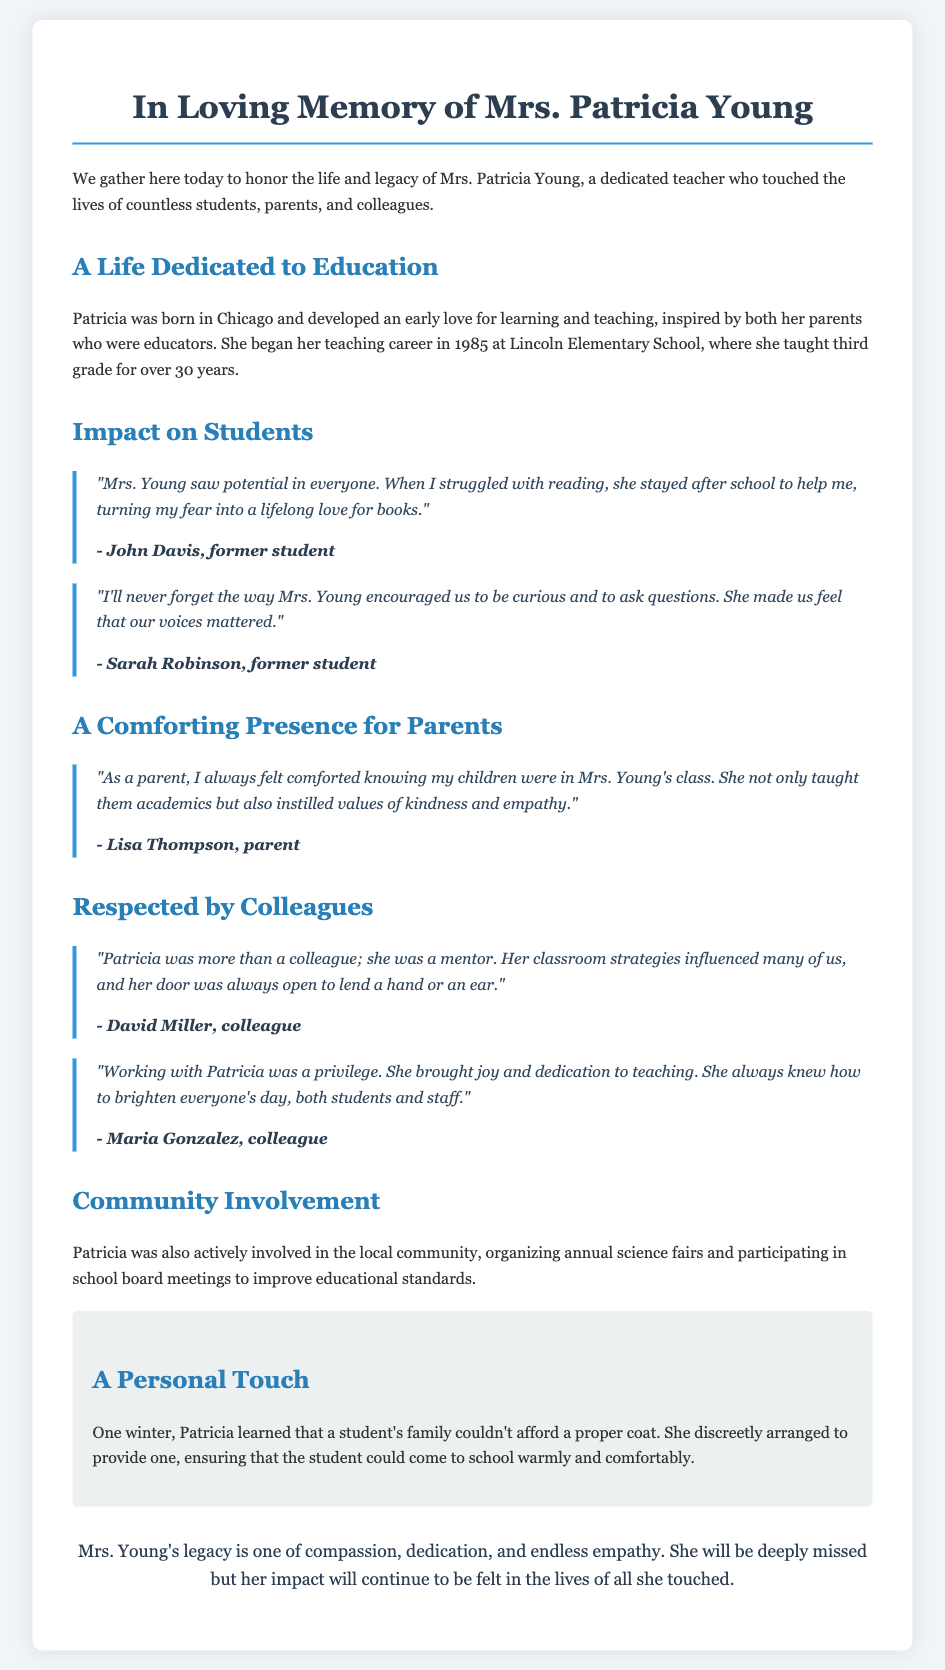What is the name of the teacher being honored? The document specifically honors Mrs. Patricia Young.
Answer: Mrs. Patricia Young In what year did Patricia begin her teaching career? The document states that Patricia began her teaching career in 1985.
Answer: 1985 How long did Patricia teach at Lincoln Elementary School? Patricia taught third grade for over 30 years, as mentioned in the document.
Answer: over 30 years Who is a former student that mentioned their experience with Mrs. Young? The document provides the name John Davis as a former student who shared an experience.
Answer: John Davis What did Patricia provide to a student during winter? The document tells us that Patricia discreetly arranged to provide a coat for a student.
Answer: coat What role did Patricia play among her colleagues? According to the document, Patricia was considered a mentor to her colleagues.
Answer: mentor What qualities did Mrs. Young instill in her students? The document mentions that Mrs. Young instilled values of kindness and empathy in her students.
Answer: kindness and empathy What community involvement activity did Patricia organize? The document states that Patricia organized annual science fairs as part of her community involvement.
Answer: annual science fairs 